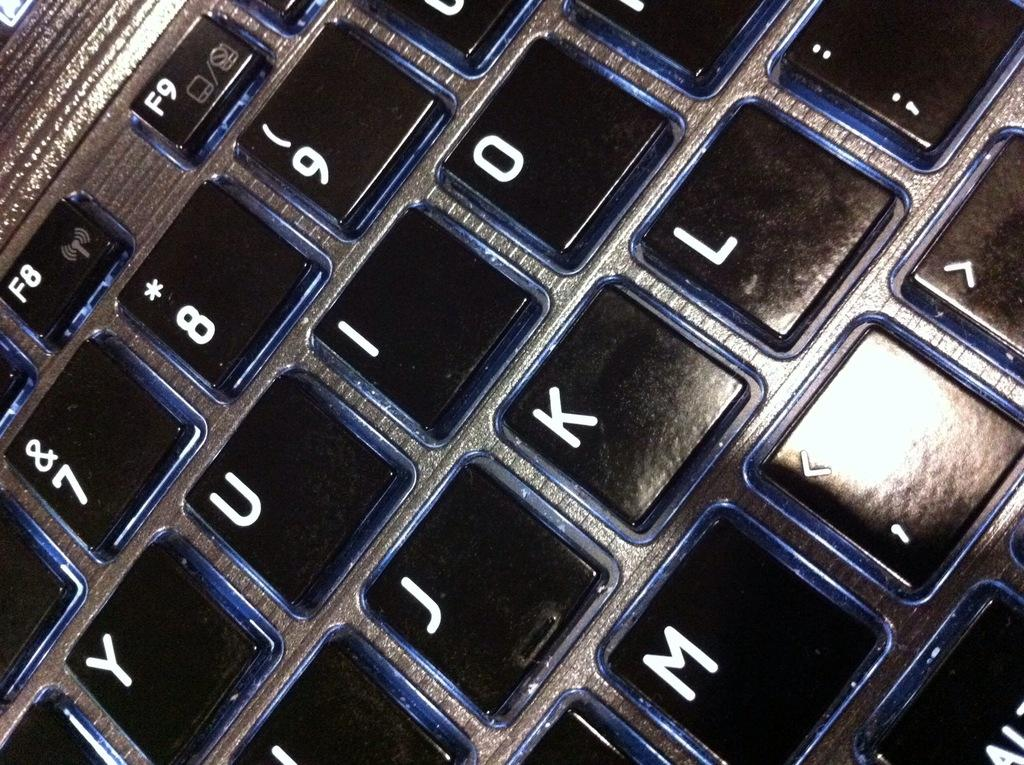Provide a one-sentence caption for the provided image. a keyboard with many different numbers on it. 